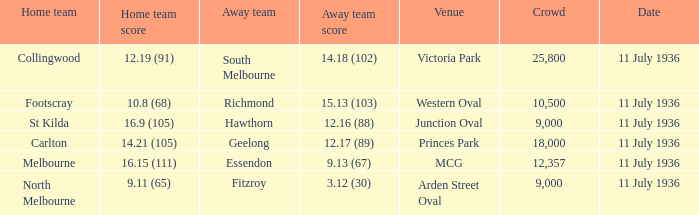When was the game with richmond as Away team? 11 July 1936. 